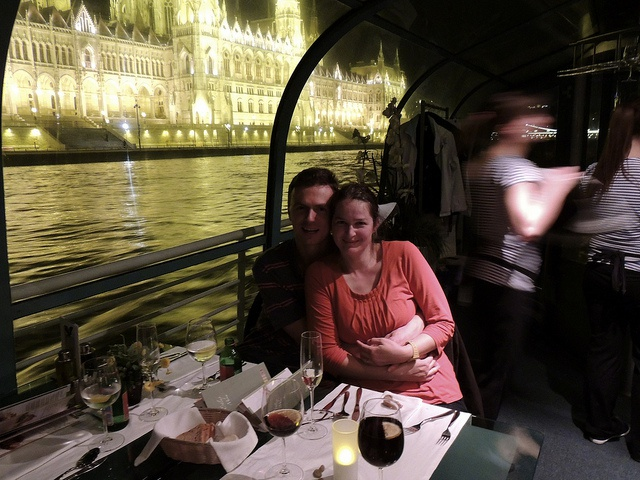Describe the objects in this image and their specific colors. I can see dining table in black, gray, darkgray, and maroon tones, people in black, lavender, gray, and maroon tones, people in black, maroon, brown, and lightpink tones, people in black, gray, and darkgray tones, and people in black, brown, maroon, and gray tones in this image. 